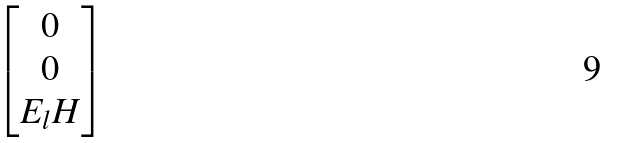Convert formula to latex. <formula><loc_0><loc_0><loc_500><loc_500>\begin{bmatrix} { 0 } \\ { 0 } \\ E _ { l } H \end{bmatrix}</formula> 